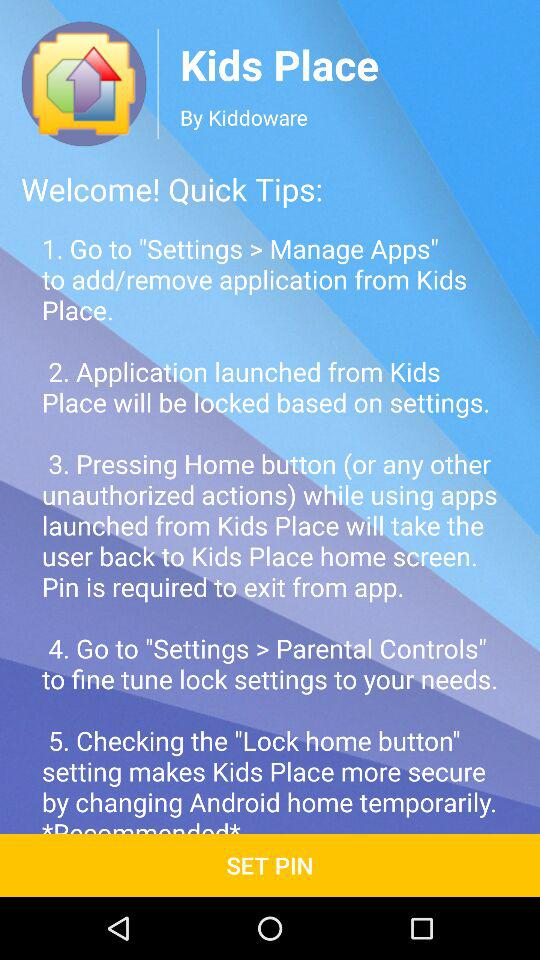What is the application name? The application name is "Kids Place". 